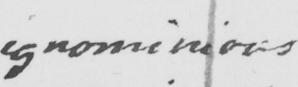What is written in this line of handwriting? ignominious 